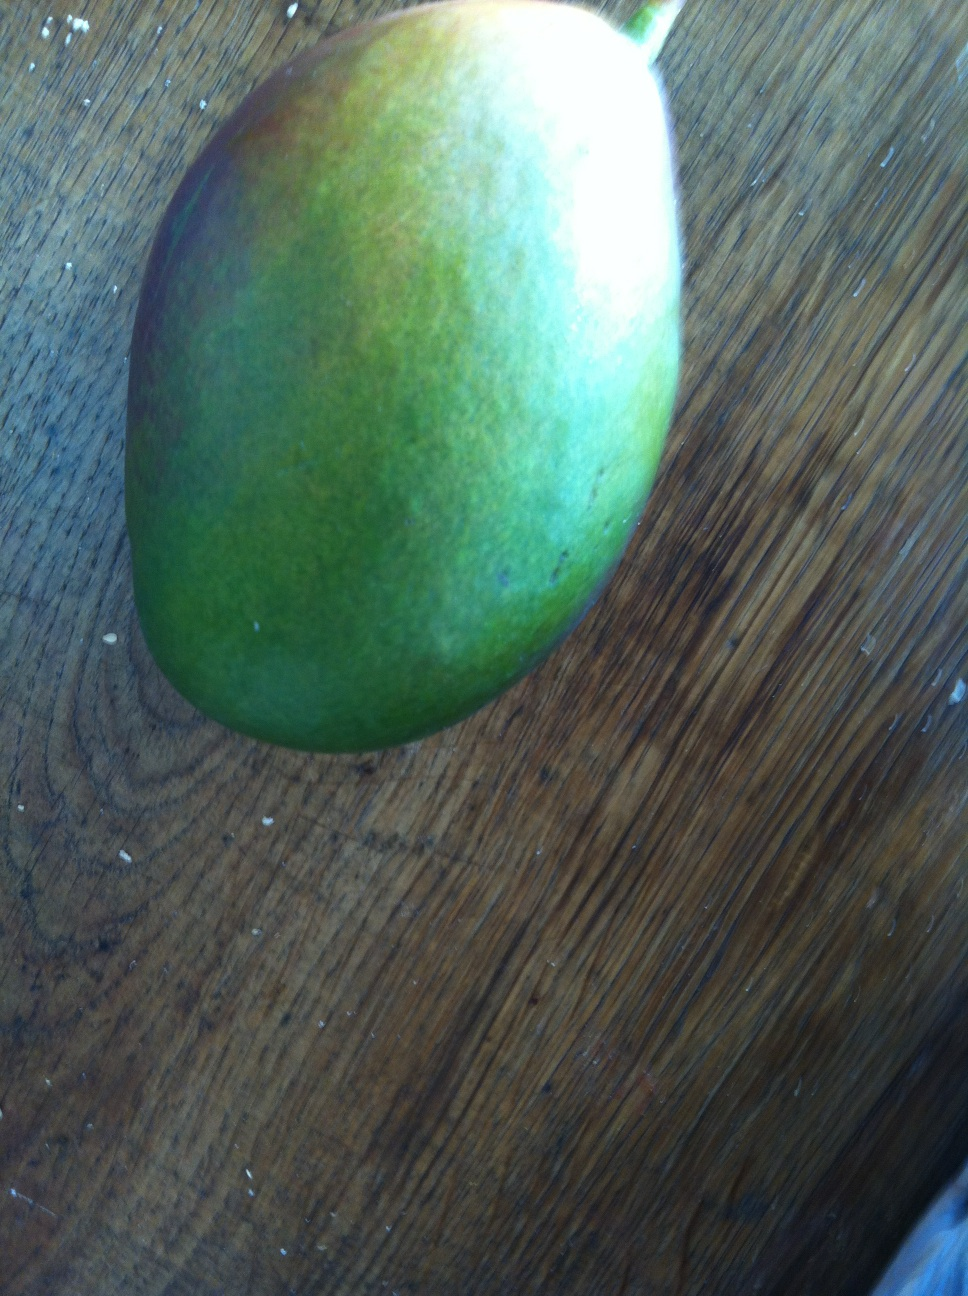What are some uses for this mango when it's at this stage of ripeness? A mango at this stage of ripeness, with its firm texture, is excellent for dishes that require the fruit to maintain its shape such as salads, salsas, or to be cubed and used as a topping. In some cultures, green mangoes are used to make pickles or chutneys which benefit from the tartness of the less ripe fruit. 